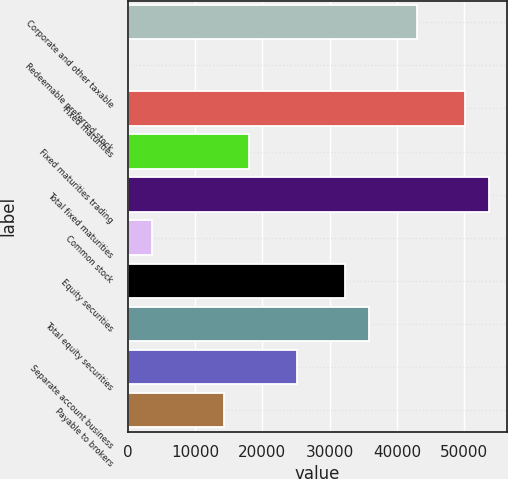Convert chart. <chart><loc_0><loc_0><loc_500><loc_500><bar_chart><fcel>Corporate and other taxable<fcel>Redeemable preferred stock<fcel>Fixed maturities<fcel>Fixed maturities trading<fcel>Total fixed maturities<fcel>Common stock<fcel>Equity securities<fcel>Total equity securities<fcel>Separate account business<fcel>Payable to brokers<nl><fcel>42968.4<fcel>54<fcel>50120.8<fcel>17935<fcel>53697<fcel>3630.2<fcel>32239.8<fcel>35816<fcel>25087.4<fcel>14358.8<nl></chart> 